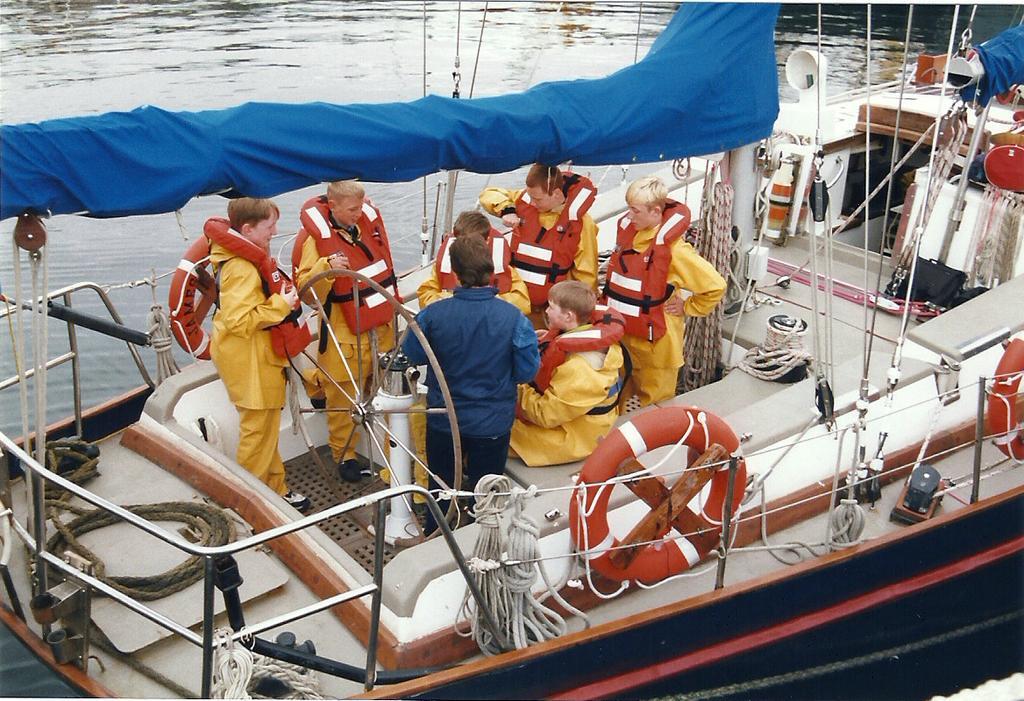In one or two sentences, can you explain what this image depicts? In this picture we can see a boat on the water and on this boat we can see some people, swim tubes, ropes and some objects. 